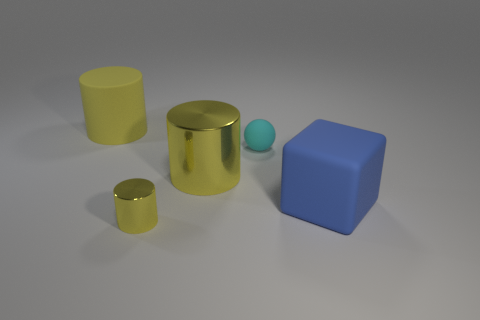Add 5 small spheres. How many objects exist? 10 Subtract all cylinders. How many objects are left? 2 Add 4 cyan things. How many cyan things exist? 5 Subtract 0 purple blocks. How many objects are left? 5 Subtract all tiny cyan matte balls. Subtract all big red metal blocks. How many objects are left? 4 Add 4 tiny yellow cylinders. How many tiny yellow cylinders are left? 5 